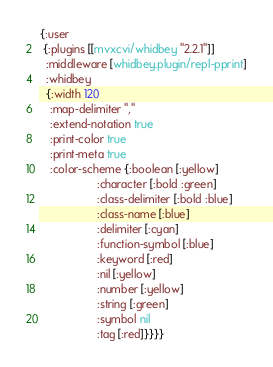Convert code to text. <code><loc_0><loc_0><loc_500><loc_500><_Clojure_>{:user
 {:plugins [[mvxcvi/whidbey "2.2.1"]]
  :middleware [whidbey.plugin/repl-pprint]
  :whidbey
  {:width 120
   :map-delimiter ","
   :extend-notation true
   :print-color true
   :print-meta true
   :color-scheme {:boolean [:yellow]
                  :character [:bold :green]
                  :class-delimiter [:bold :blue]
                  :class-name [:blue]
                  :delimiter [:cyan]
                  :function-symbol [:blue]
                  :keyword [:red]
                  :nil [:yellow]
                  :number [:yellow]
                  :string [:green]
                  :symbol nil
                  :tag [:red]}}}}
</code> 